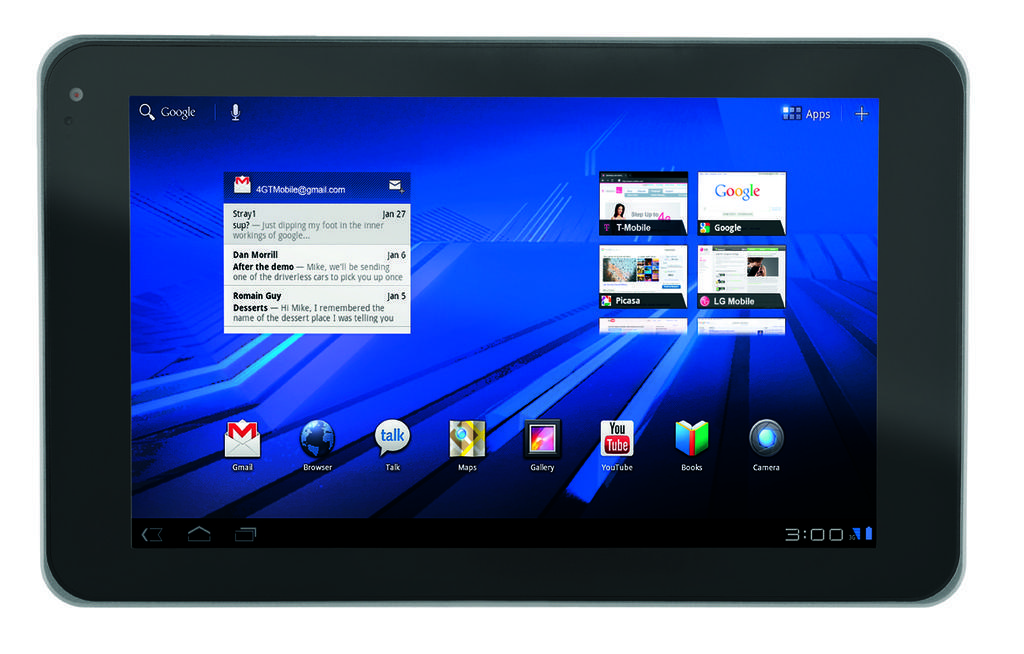How would you summarize this image in a sentence or two? In this image there is one screen, in that screen there is some text. 